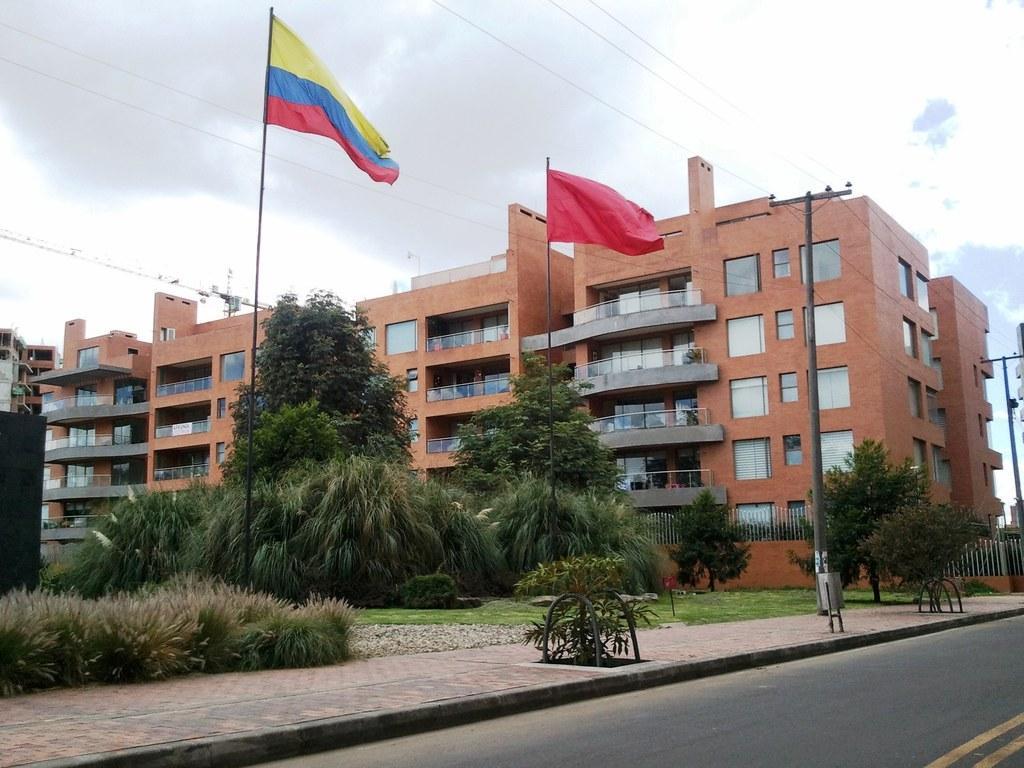How would you summarize this image in a sentence or two? In this image there is a building. In the foreground there are flags, poles and trees. There is a crane behind the building. At the top there is sky and there are clouds and wires. At the bottom there is grass and there is a road. 